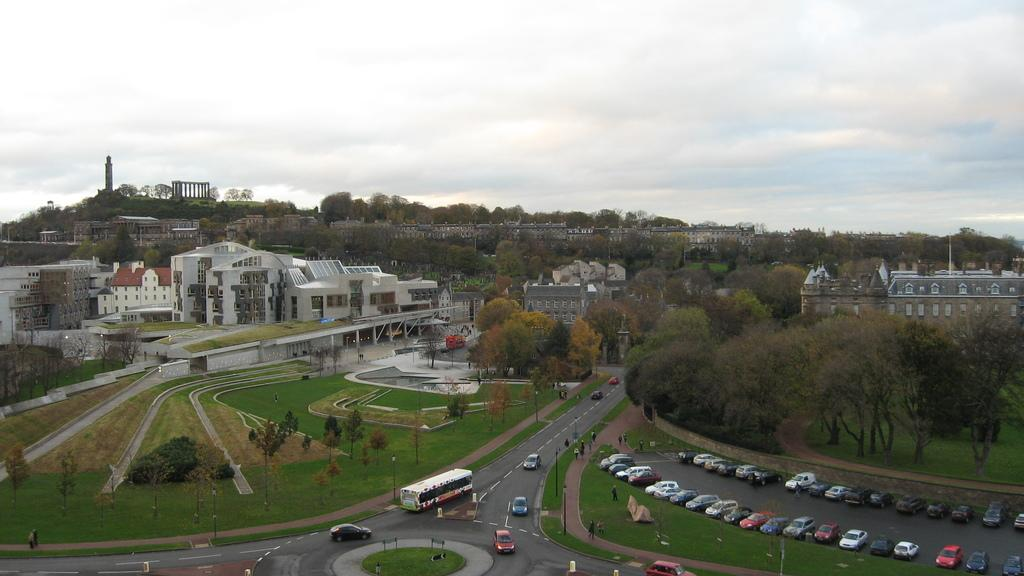What can be seen on the road in the image? There are vehicles on the road in the image. What type of vegetation is visible in the image? There is grass, plants, and trees visible in the image. What structures can be seen in the image? There are poles and buildings visible in the image. What is visible in the background of the image? The sky is visible in the background of the image, and there are clouds in the sky. Can you see any stitches on the vehicles in the image? There are no stitches visible on the vehicles in the image. Is there any quicksand present in the image? There is no quicksand present in the image. 